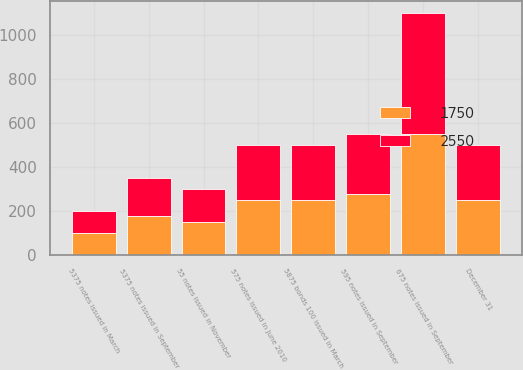Convert chart to OTSL. <chart><loc_0><loc_0><loc_500><loc_500><stacked_bar_chart><ecel><fcel>December 31<fcel>5375 notes issued in March<fcel>55 notes issued in November<fcel>595 notes issued in September<fcel>5375 notes issued in September<fcel>675 notes issued in September<fcel>575 notes issued in June 2010<fcel>5875 bonds 100 issued in March<nl><fcel>2550<fcel>250<fcel>100<fcel>150<fcel>275<fcel>175<fcel>550<fcel>250<fcel>250<nl><fcel>1750<fcel>250<fcel>100<fcel>150<fcel>275<fcel>175<fcel>550<fcel>250<fcel>250<nl></chart> 